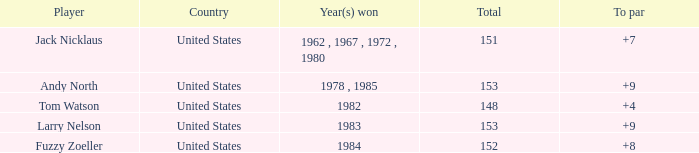What is the Total of the Player with a To par of 4? 1.0. 